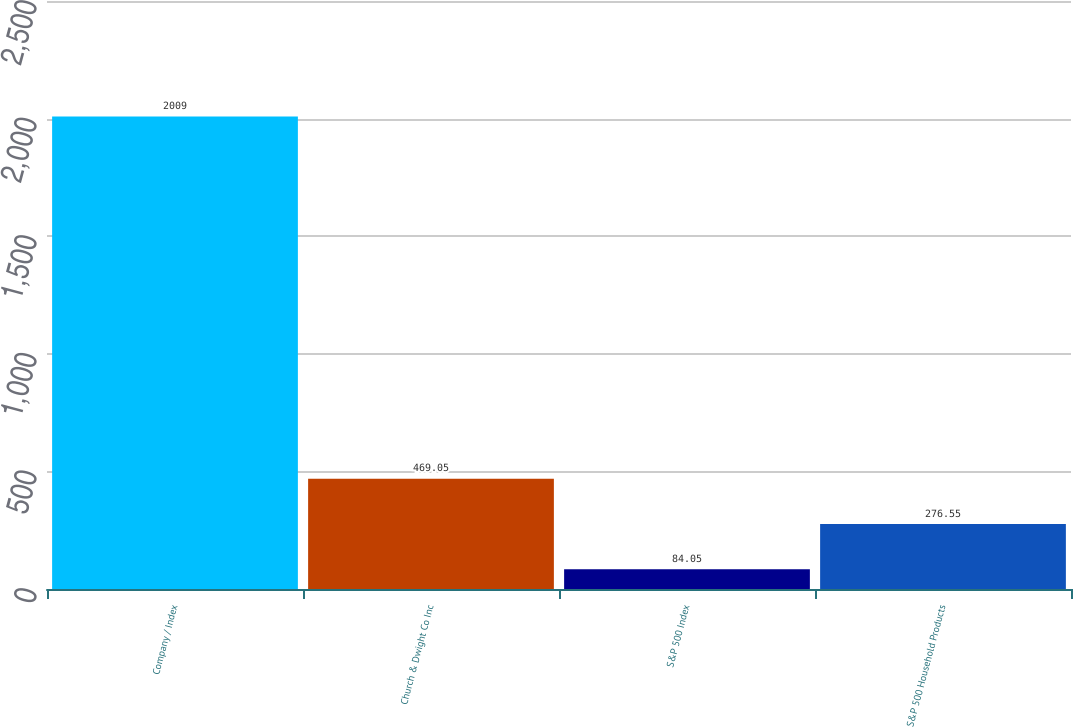Convert chart to OTSL. <chart><loc_0><loc_0><loc_500><loc_500><bar_chart><fcel>Company / Index<fcel>Church & Dwight Co Inc<fcel>S&P 500 Index<fcel>S&P 500 Household Products<nl><fcel>2009<fcel>469.05<fcel>84.05<fcel>276.55<nl></chart> 